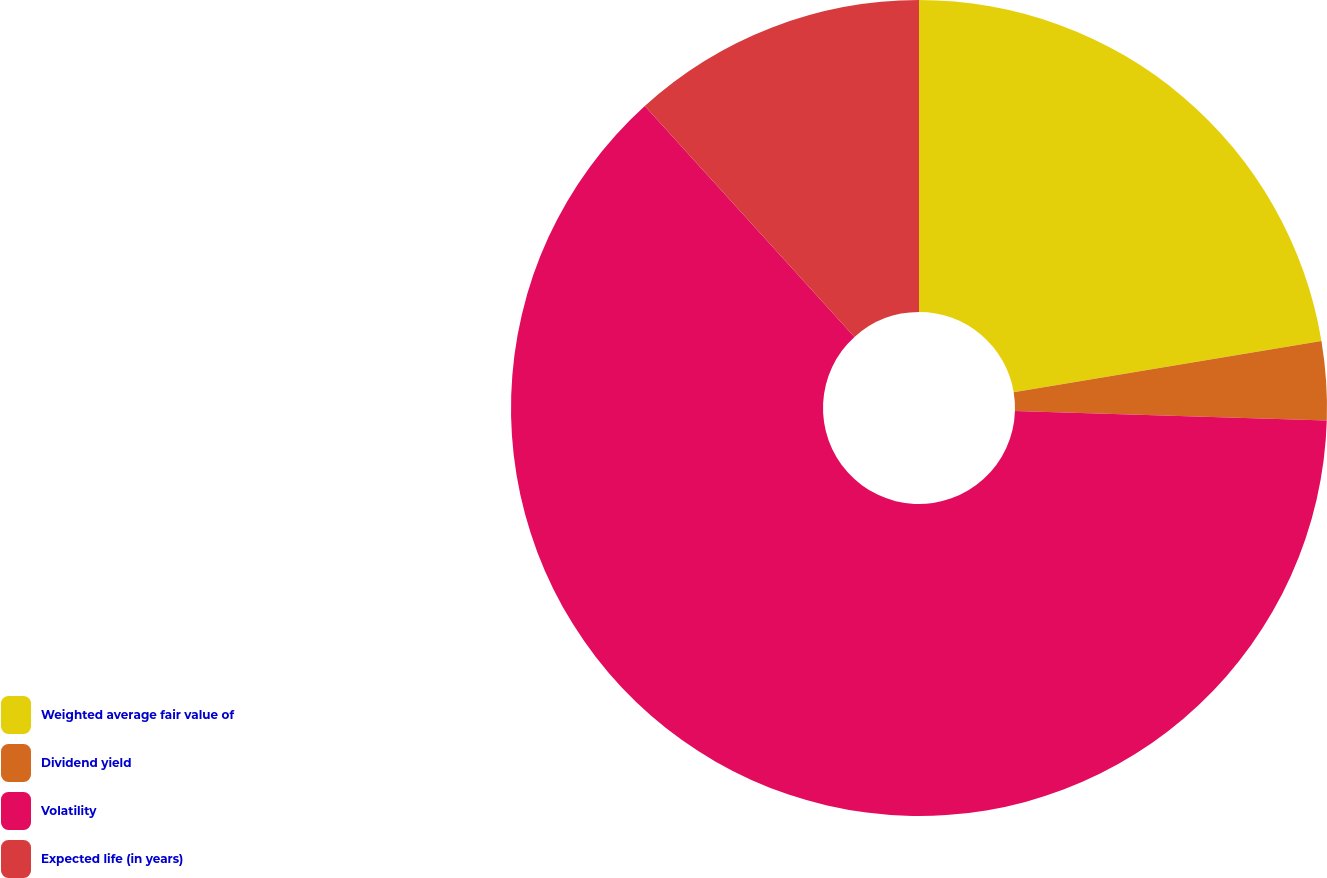Convert chart to OTSL. <chart><loc_0><loc_0><loc_500><loc_500><pie_chart><fcel>Weighted average fair value of<fcel>Dividend yield<fcel>Volatility<fcel>Expected life (in years)<nl><fcel>22.37%<fcel>3.12%<fcel>62.78%<fcel>11.73%<nl></chart> 